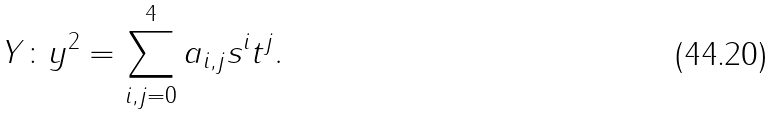Convert formula to latex. <formula><loc_0><loc_0><loc_500><loc_500>Y \colon y ^ { 2 } = \sum _ { i , j = 0 } ^ { 4 } a _ { i , j } s ^ { i } t ^ { j } .</formula> 